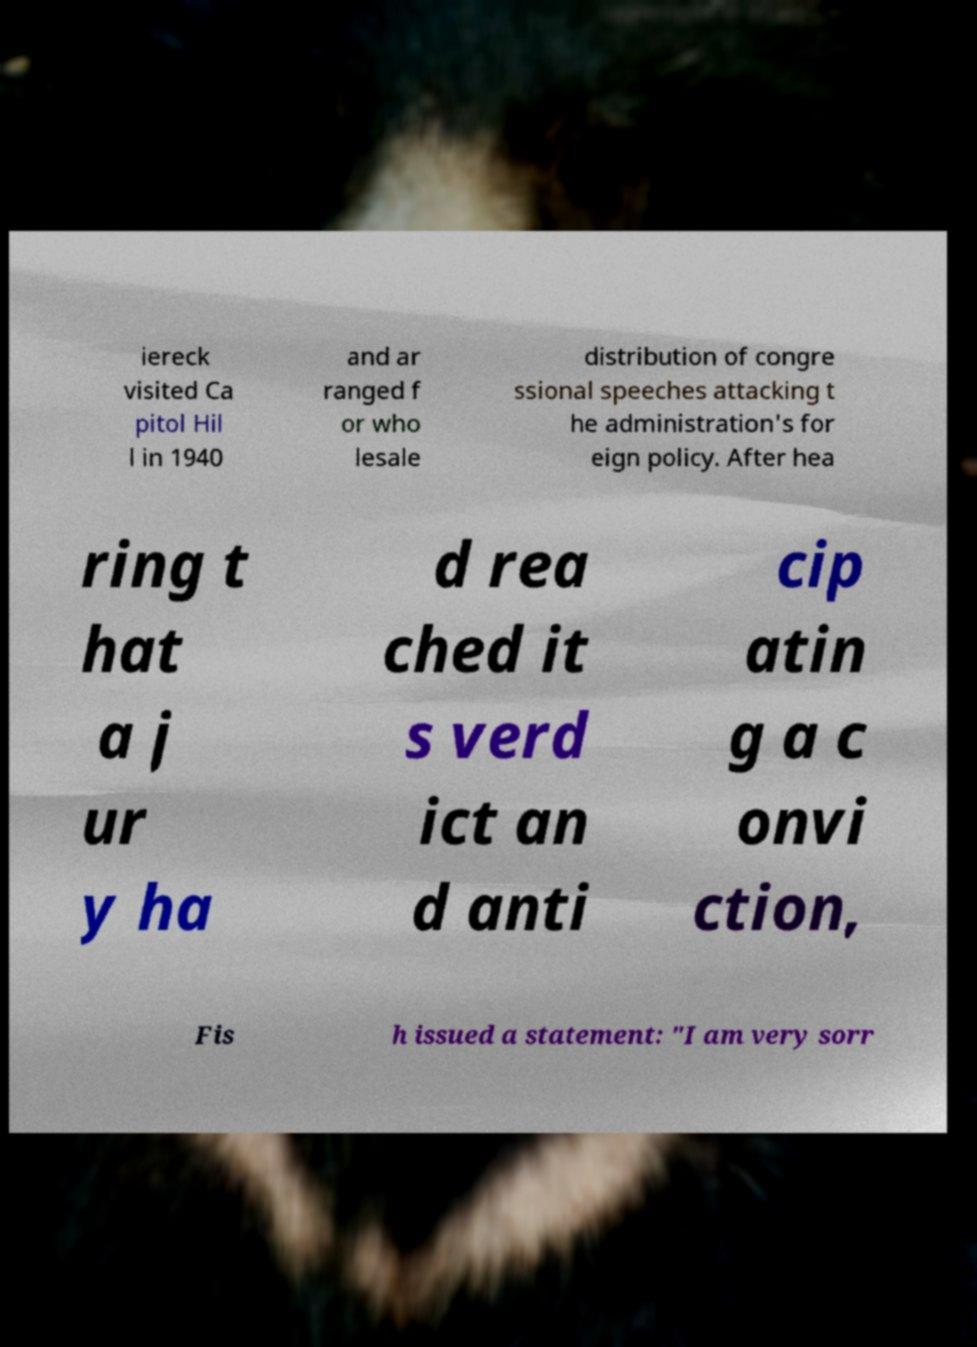Could you assist in decoding the text presented in this image and type it out clearly? iereck visited Ca pitol Hil l in 1940 and ar ranged f or who lesale distribution of congre ssional speeches attacking t he administration's for eign policy. After hea ring t hat a j ur y ha d rea ched it s verd ict an d anti cip atin g a c onvi ction, Fis h issued a statement: "I am very sorr 